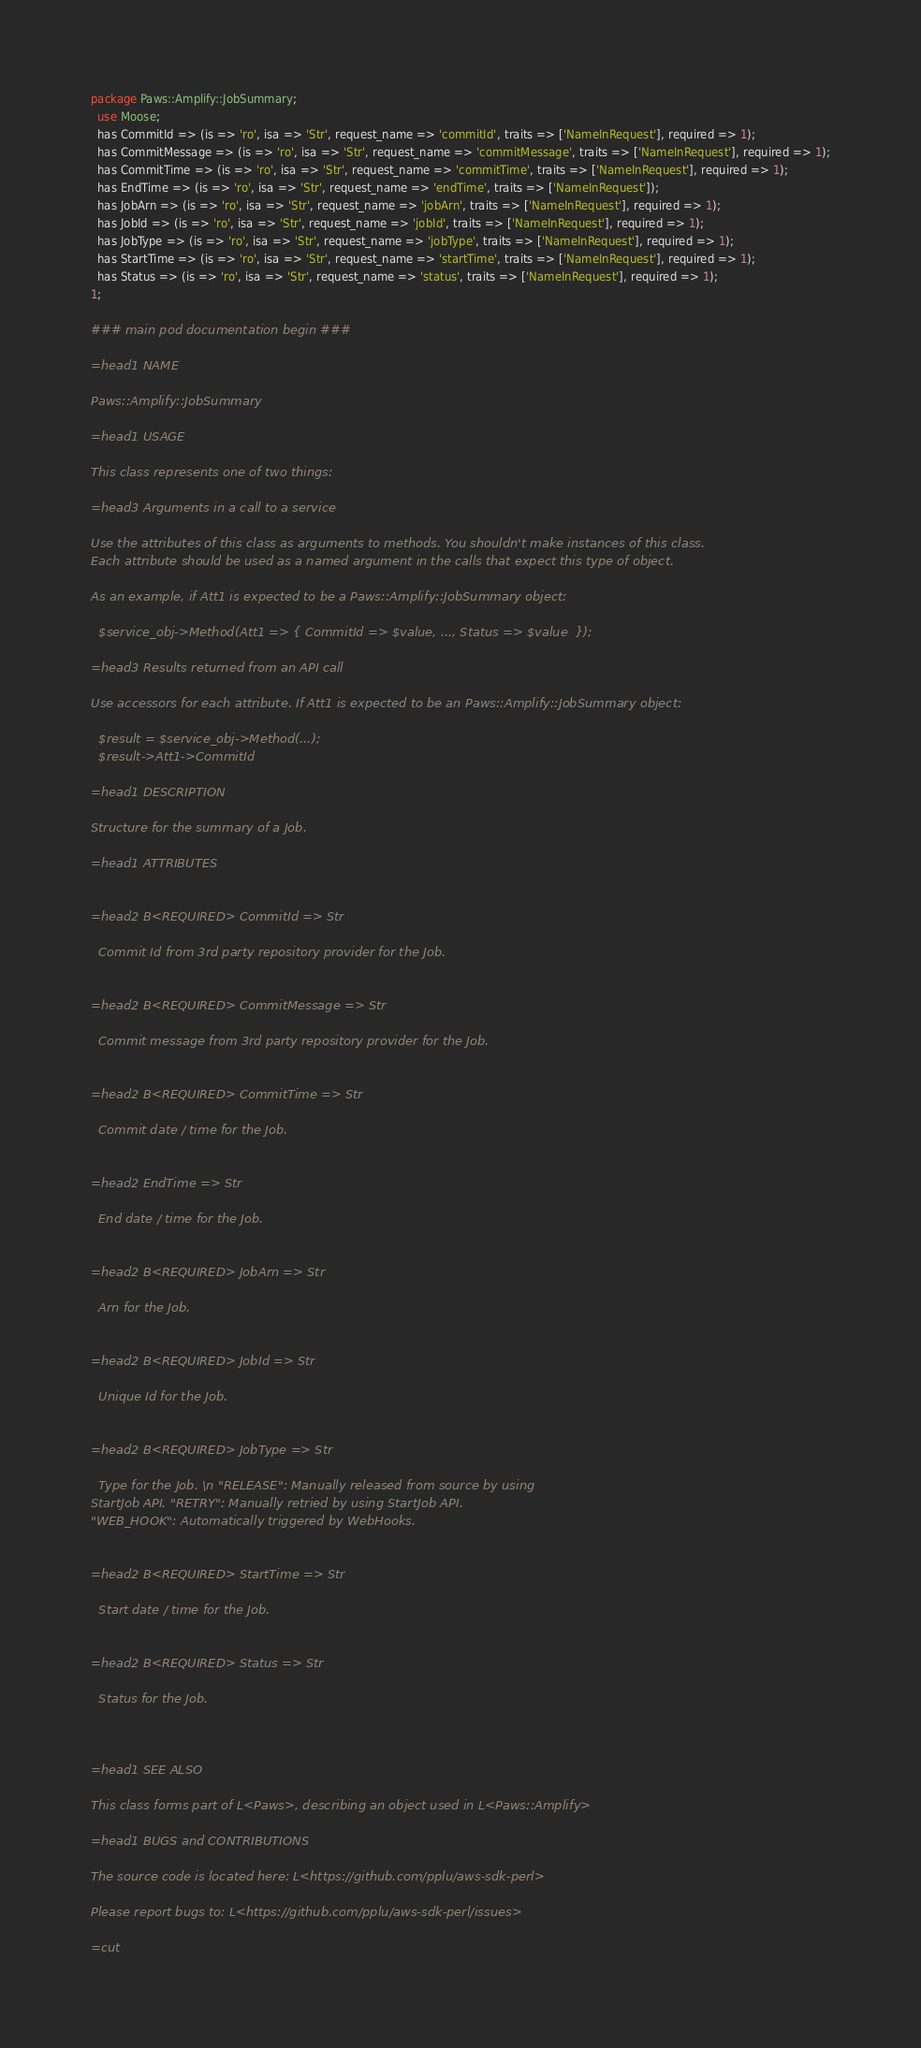Convert code to text. <code><loc_0><loc_0><loc_500><loc_500><_Perl_>package Paws::Amplify::JobSummary;
  use Moose;
  has CommitId => (is => 'ro', isa => 'Str', request_name => 'commitId', traits => ['NameInRequest'], required => 1);
  has CommitMessage => (is => 'ro', isa => 'Str', request_name => 'commitMessage', traits => ['NameInRequest'], required => 1);
  has CommitTime => (is => 'ro', isa => 'Str', request_name => 'commitTime', traits => ['NameInRequest'], required => 1);
  has EndTime => (is => 'ro', isa => 'Str', request_name => 'endTime', traits => ['NameInRequest']);
  has JobArn => (is => 'ro', isa => 'Str', request_name => 'jobArn', traits => ['NameInRequest'], required => 1);
  has JobId => (is => 'ro', isa => 'Str', request_name => 'jobId', traits => ['NameInRequest'], required => 1);
  has JobType => (is => 'ro', isa => 'Str', request_name => 'jobType', traits => ['NameInRequest'], required => 1);
  has StartTime => (is => 'ro', isa => 'Str', request_name => 'startTime', traits => ['NameInRequest'], required => 1);
  has Status => (is => 'ro', isa => 'Str', request_name => 'status', traits => ['NameInRequest'], required => 1);
1;

### main pod documentation begin ###

=head1 NAME

Paws::Amplify::JobSummary

=head1 USAGE

This class represents one of two things:

=head3 Arguments in a call to a service

Use the attributes of this class as arguments to methods. You shouldn't make instances of this class. 
Each attribute should be used as a named argument in the calls that expect this type of object.

As an example, if Att1 is expected to be a Paws::Amplify::JobSummary object:

  $service_obj->Method(Att1 => { CommitId => $value, ..., Status => $value  });

=head3 Results returned from an API call

Use accessors for each attribute. If Att1 is expected to be an Paws::Amplify::JobSummary object:

  $result = $service_obj->Method(...);
  $result->Att1->CommitId

=head1 DESCRIPTION

Structure for the summary of a Job.

=head1 ATTRIBUTES


=head2 B<REQUIRED> CommitId => Str

  Commit Id from 3rd party repository provider for the Job.


=head2 B<REQUIRED> CommitMessage => Str

  Commit message from 3rd party repository provider for the Job.


=head2 B<REQUIRED> CommitTime => Str

  Commit date / time for the Job.


=head2 EndTime => Str

  End date / time for the Job.


=head2 B<REQUIRED> JobArn => Str

  Arn for the Job.


=head2 B<REQUIRED> JobId => Str

  Unique Id for the Job.


=head2 B<REQUIRED> JobType => Str

  Type for the Job. \n "RELEASE": Manually released from source by using
StartJob API. "RETRY": Manually retried by using StartJob API.
"WEB_HOOK": Automatically triggered by WebHooks.


=head2 B<REQUIRED> StartTime => Str

  Start date / time for the Job.


=head2 B<REQUIRED> Status => Str

  Status for the Job.



=head1 SEE ALSO

This class forms part of L<Paws>, describing an object used in L<Paws::Amplify>

=head1 BUGS and CONTRIBUTIONS

The source code is located here: L<https://github.com/pplu/aws-sdk-perl>

Please report bugs to: L<https://github.com/pplu/aws-sdk-perl/issues>

=cut

</code> 